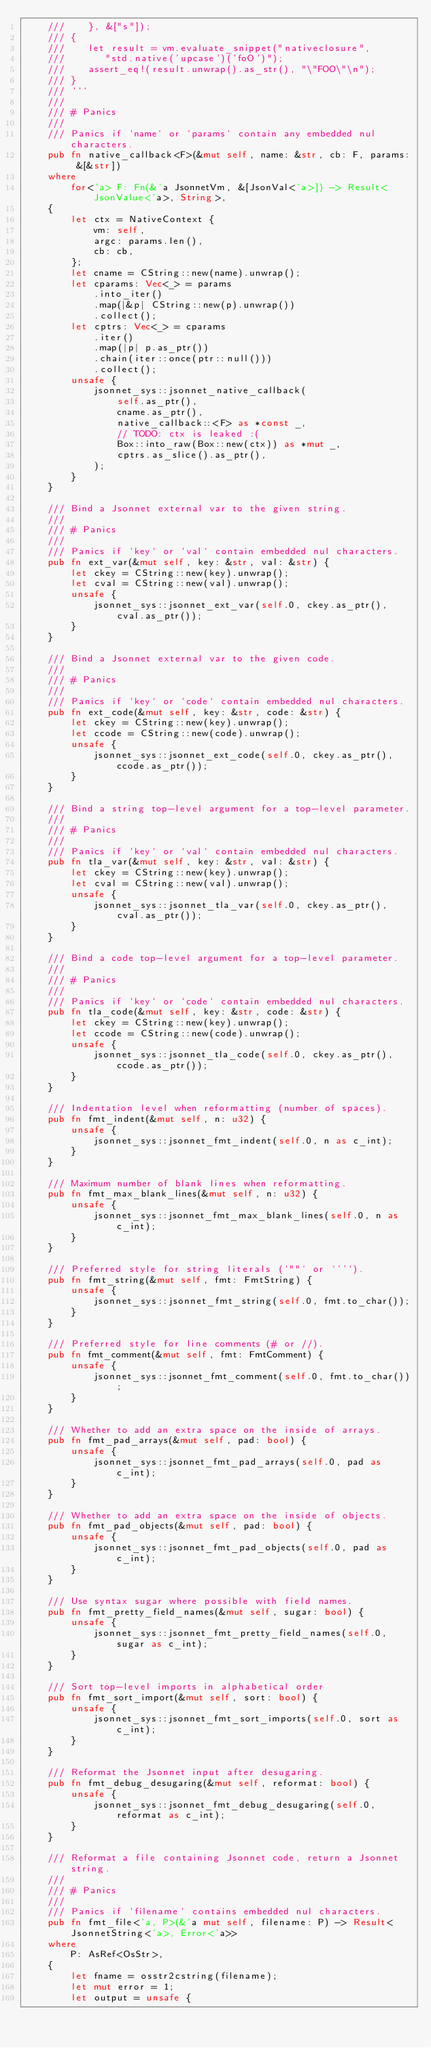<code> <loc_0><loc_0><loc_500><loc_500><_Rust_>    ///    }, &["s"]);
    /// {
    ///    let result = vm.evaluate_snippet("nativeclosure",
    ///       "std.native('upcase')('foO')");
    ///    assert_eq!(result.unwrap().as_str(), "\"FOO\"\n");
    /// }
    /// ```
    ///
    /// # Panics
    ///
    /// Panics if `name` or `params` contain any embedded nul characters.
    pub fn native_callback<F>(&mut self, name: &str, cb: F, params: &[&str])
    where
        for<'a> F: Fn(&'a JsonnetVm, &[JsonVal<'a>]) -> Result<JsonValue<'a>, String>,
    {
        let ctx = NativeContext {
            vm: self,
            argc: params.len(),
            cb: cb,
        };
        let cname = CString::new(name).unwrap();
        let cparams: Vec<_> = params
            .into_iter()
            .map(|&p| CString::new(p).unwrap())
            .collect();
        let cptrs: Vec<_> = cparams
            .iter()
            .map(|p| p.as_ptr())
            .chain(iter::once(ptr::null()))
            .collect();
        unsafe {
            jsonnet_sys::jsonnet_native_callback(
                self.as_ptr(),
                cname.as_ptr(),
                native_callback::<F> as *const _,
                // TODO: ctx is leaked :(
                Box::into_raw(Box::new(ctx)) as *mut _,
                cptrs.as_slice().as_ptr(),
            );
        }
    }

    /// Bind a Jsonnet external var to the given string.
    ///
    /// # Panics
    ///
    /// Panics if `key` or `val` contain embedded nul characters.
    pub fn ext_var(&mut self, key: &str, val: &str) {
        let ckey = CString::new(key).unwrap();
        let cval = CString::new(val).unwrap();
        unsafe {
            jsonnet_sys::jsonnet_ext_var(self.0, ckey.as_ptr(), cval.as_ptr());
        }
    }

    /// Bind a Jsonnet external var to the given code.
    ///
    /// # Panics
    ///
    /// Panics if `key` or `code` contain embedded nul characters.
    pub fn ext_code(&mut self, key: &str, code: &str) {
        let ckey = CString::new(key).unwrap();
        let ccode = CString::new(code).unwrap();
        unsafe {
            jsonnet_sys::jsonnet_ext_code(self.0, ckey.as_ptr(), ccode.as_ptr());
        }
    }

    /// Bind a string top-level argument for a top-level parameter.
    ///
    /// # Panics
    ///
    /// Panics if `key` or `val` contain embedded nul characters.
    pub fn tla_var(&mut self, key: &str, val: &str) {
        let ckey = CString::new(key).unwrap();
        let cval = CString::new(val).unwrap();
        unsafe {
            jsonnet_sys::jsonnet_tla_var(self.0, ckey.as_ptr(), cval.as_ptr());
        }
    }

    /// Bind a code top-level argument for a top-level parameter.
    ///
    /// # Panics
    ///
    /// Panics if `key` or `code` contain embedded nul characters.
    pub fn tla_code(&mut self, key: &str, code: &str) {
        let ckey = CString::new(key).unwrap();
        let ccode = CString::new(code).unwrap();
        unsafe {
            jsonnet_sys::jsonnet_tla_code(self.0, ckey.as_ptr(), ccode.as_ptr());
        }
    }

    /// Indentation level when reformatting (number of spaces).
    pub fn fmt_indent(&mut self, n: u32) {
        unsafe {
            jsonnet_sys::jsonnet_fmt_indent(self.0, n as c_int);
        }
    }

    /// Maximum number of blank lines when reformatting.
    pub fn fmt_max_blank_lines(&mut self, n: u32) {
        unsafe {
            jsonnet_sys::jsonnet_fmt_max_blank_lines(self.0, n as c_int);
        }
    }

    /// Preferred style for string literals (`""` or `''`).
    pub fn fmt_string(&mut self, fmt: FmtString) {
        unsafe {
            jsonnet_sys::jsonnet_fmt_string(self.0, fmt.to_char());
        }
    }

    /// Preferred style for line comments (# or //).
    pub fn fmt_comment(&mut self, fmt: FmtComment) {
        unsafe {
            jsonnet_sys::jsonnet_fmt_comment(self.0, fmt.to_char());
        }
    }

    /// Whether to add an extra space on the inside of arrays.
    pub fn fmt_pad_arrays(&mut self, pad: bool) {
        unsafe {
            jsonnet_sys::jsonnet_fmt_pad_arrays(self.0, pad as c_int);
        }
    }

    /// Whether to add an extra space on the inside of objects.
    pub fn fmt_pad_objects(&mut self, pad: bool) {
        unsafe {
            jsonnet_sys::jsonnet_fmt_pad_objects(self.0, pad as c_int);
        }
    }

    /// Use syntax sugar where possible with field names.
    pub fn fmt_pretty_field_names(&mut self, sugar: bool) {
        unsafe {
            jsonnet_sys::jsonnet_fmt_pretty_field_names(self.0, sugar as c_int);
        }
    }

    /// Sort top-level imports in alphabetical order
    pub fn fmt_sort_import(&mut self, sort: bool) {
        unsafe {
            jsonnet_sys::jsonnet_fmt_sort_imports(self.0, sort as c_int);
        }
    }

    /// Reformat the Jsonnet input after desugaring.
    pub fn fmt_debug_desugaring(&mut self, reformat: bool) {
        unsafe {
            jsonnet_sys::jsonnet_fmt_debug_desugaring(self.0, reformat as c_int);
        }
    }

    /// Reformat a file containing Jsonnet code, return a Jsonnet string.
    ///
    /// # Panics
    ///
    /// Panics if `filename` contains embedded nul characters.
    pub fn fmt_file<'a, P>(&'a mut self, filename: P) -> Result<JsonnetString<'a>, Error<'a>>
    where
        P: AsRef<OsStr>,
    {
        let fname = osstr2cstring(filename);
        let mut error = 1;
        let output = unsafe {</code> 